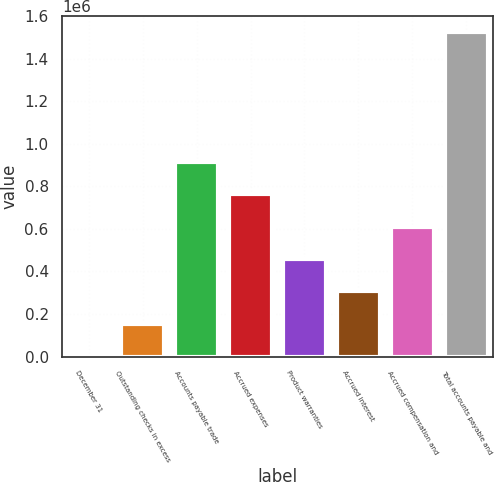Convert chart. <chart><loc_0><loc_0><loc_500><loc_500><bar_chart><fcel>December 31<fcel>Outstanding checks in excess<fcel>Accounts payable trade<fcel>Accrued expenses<fcel>Product warranties<fcel>Accrued interest<fcel>Accrued compensation and<fcel>Total accounts payable and<nl><fcel>2018<fcel>154203<fcel>915127<fcel>762942<fcel>458572<fcel>306388<fcel>610757<fcel>1.52387e+06<nl></chart> 